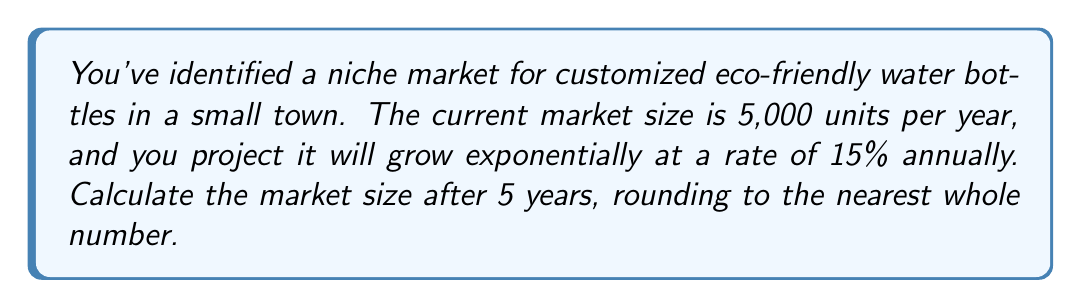Can you solve this math problem? To solve this problem, we'll use the exponential growth formula:

$$A = P(1 + r)^t$$

Where:
$A$ = Final amount
$P$ = Initial amount (principal)
$r$ = Growth rate (as a decimal)
$t$ = Time period

Given:
$P = 5,000$ (initial market size)
$r = 0.15$ (15% growth rate)
$t = 5$ years

Let's substitute these values into the formula:

$$A = 5,000(1 + 0.15)^5$$

Now, let's calculate step by step:

1) First, calculate $(1 + 0.15)$:
   $1 + 0.15 = 1.15$

2) Now, raise 1.15 to the power of 5:
   $1.15^5 \approx 2.0113689$

3) Multiply this by the initial amount:
   $5,000 \times 2.0113689 \approx 10,056.8445$

4) Round to the nearest whole number:
   $10,057$

Therefore, the market size after 5 years will be approximately 10,057 units.
Answer: 10,057 units 